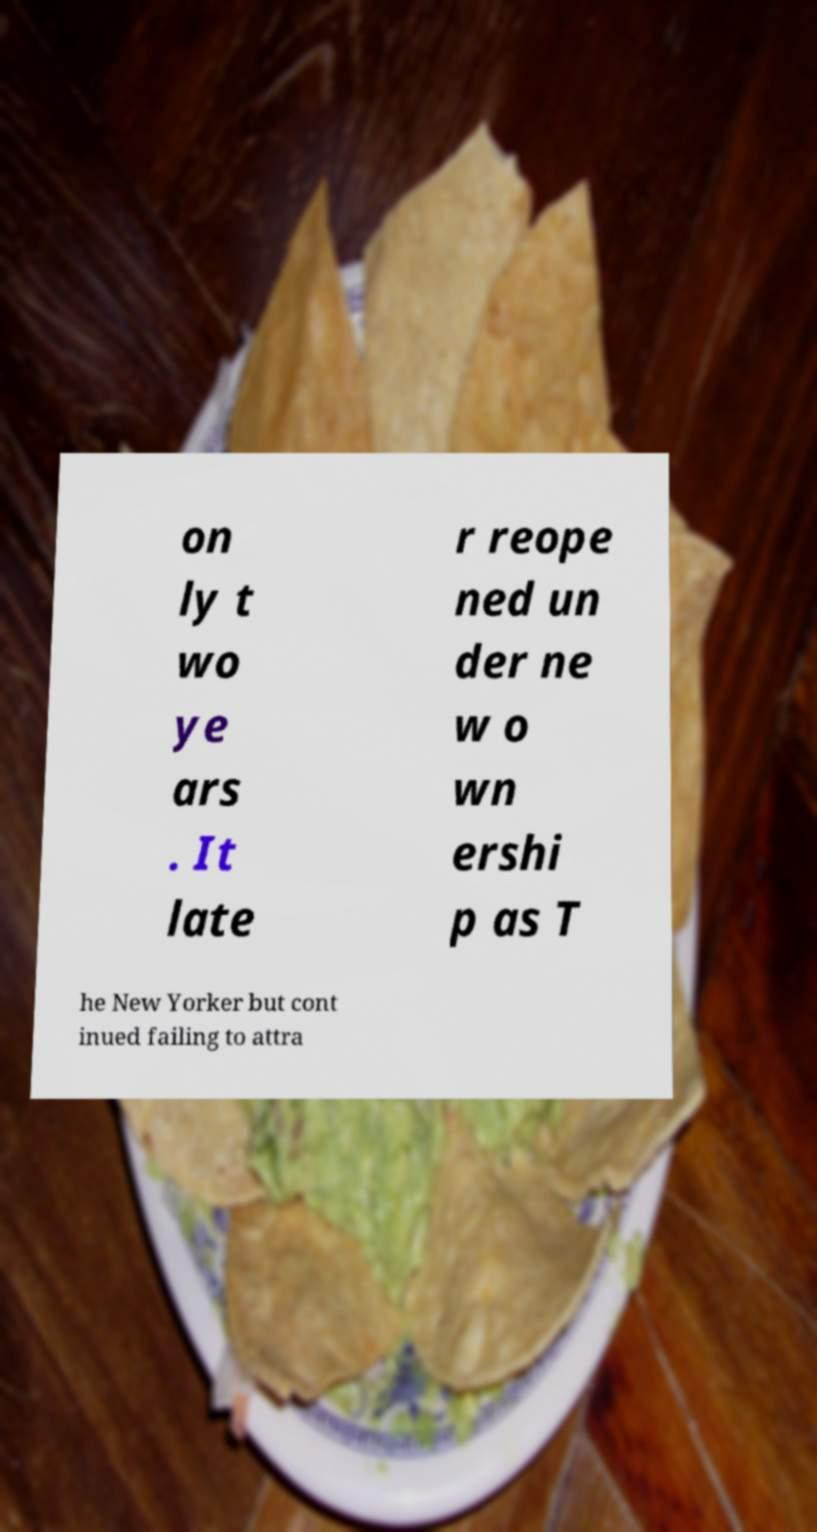There's text embedded in this image that I need extracted. Can you transcribe it verbatim? on ly t wo ye ars . It late r reope ned un der ne w o wn ershi p as T he New Yorker but cont inued failing to attra 